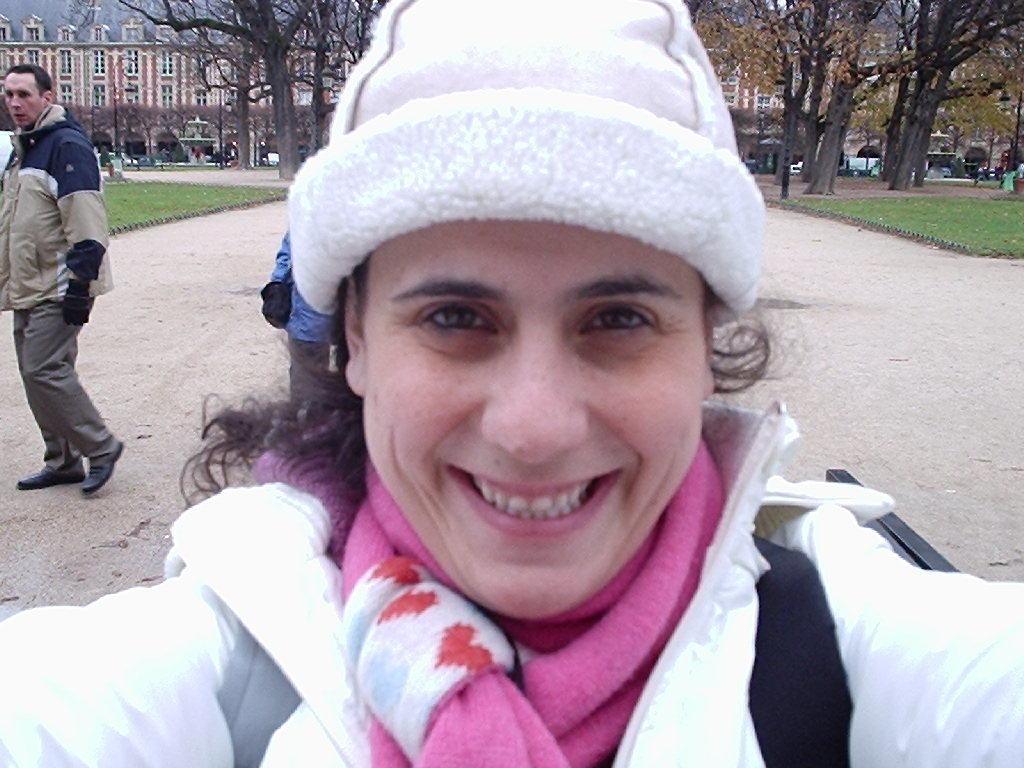Could you give a brief overview of what you see in this image? This is the picture of a person wearing jacket, hat and behind there are some trees, plants, buildings, people and some vehicles. 